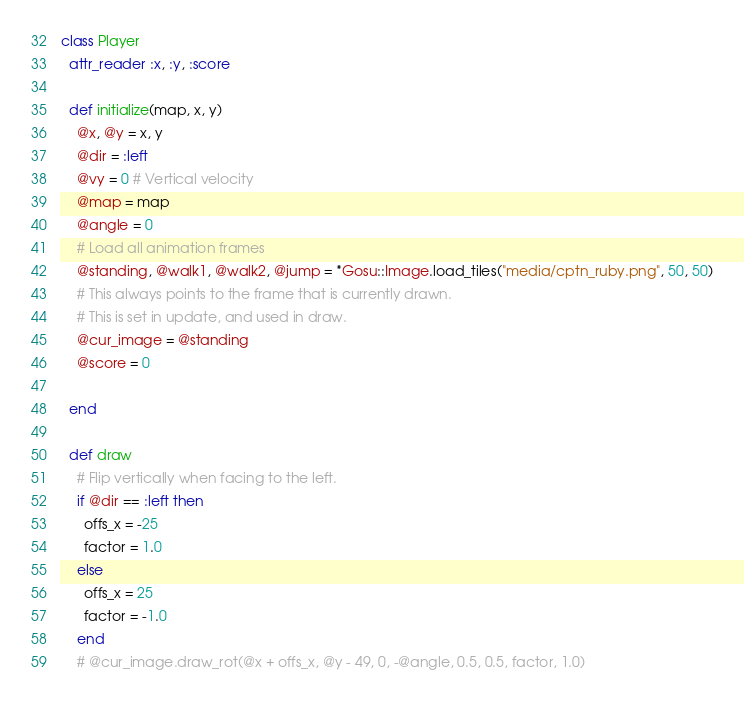Convert code to text. <code><loc_0><loc_0><loc_500><loc_500><_Ruby_>

class Player
  attr_reader :x, :y, :score

  def initialize(map, x, y)
    @x, @y = x, y
    @dir = :left
    @vy = 0 # Vertical velocity
    @map = map
    @angle = 0
    # Load all animation frames
    @standing, @walk1, @walk2, @jump = *Gosu::Image.load_tiles("media/cptn_ruby.png", 50, 50)
    # This always points to the frame that is currently drawn.
    # This is set in update, and used in draw.
    @cur_image = @standing
    @score = 0
    
  end

  def draw
    # Flip vertically when facing to the left.
    if @dir == :left then
      offs_x = -25
      factor = 1.0
    else
      offs_x = 25
      factor = -1.0
    end
    # @cur_image.draw_rot(@x + offs_x, @y - 49, 0, -@angle, 0.5, 0.5, factor, 1.0)</code> 